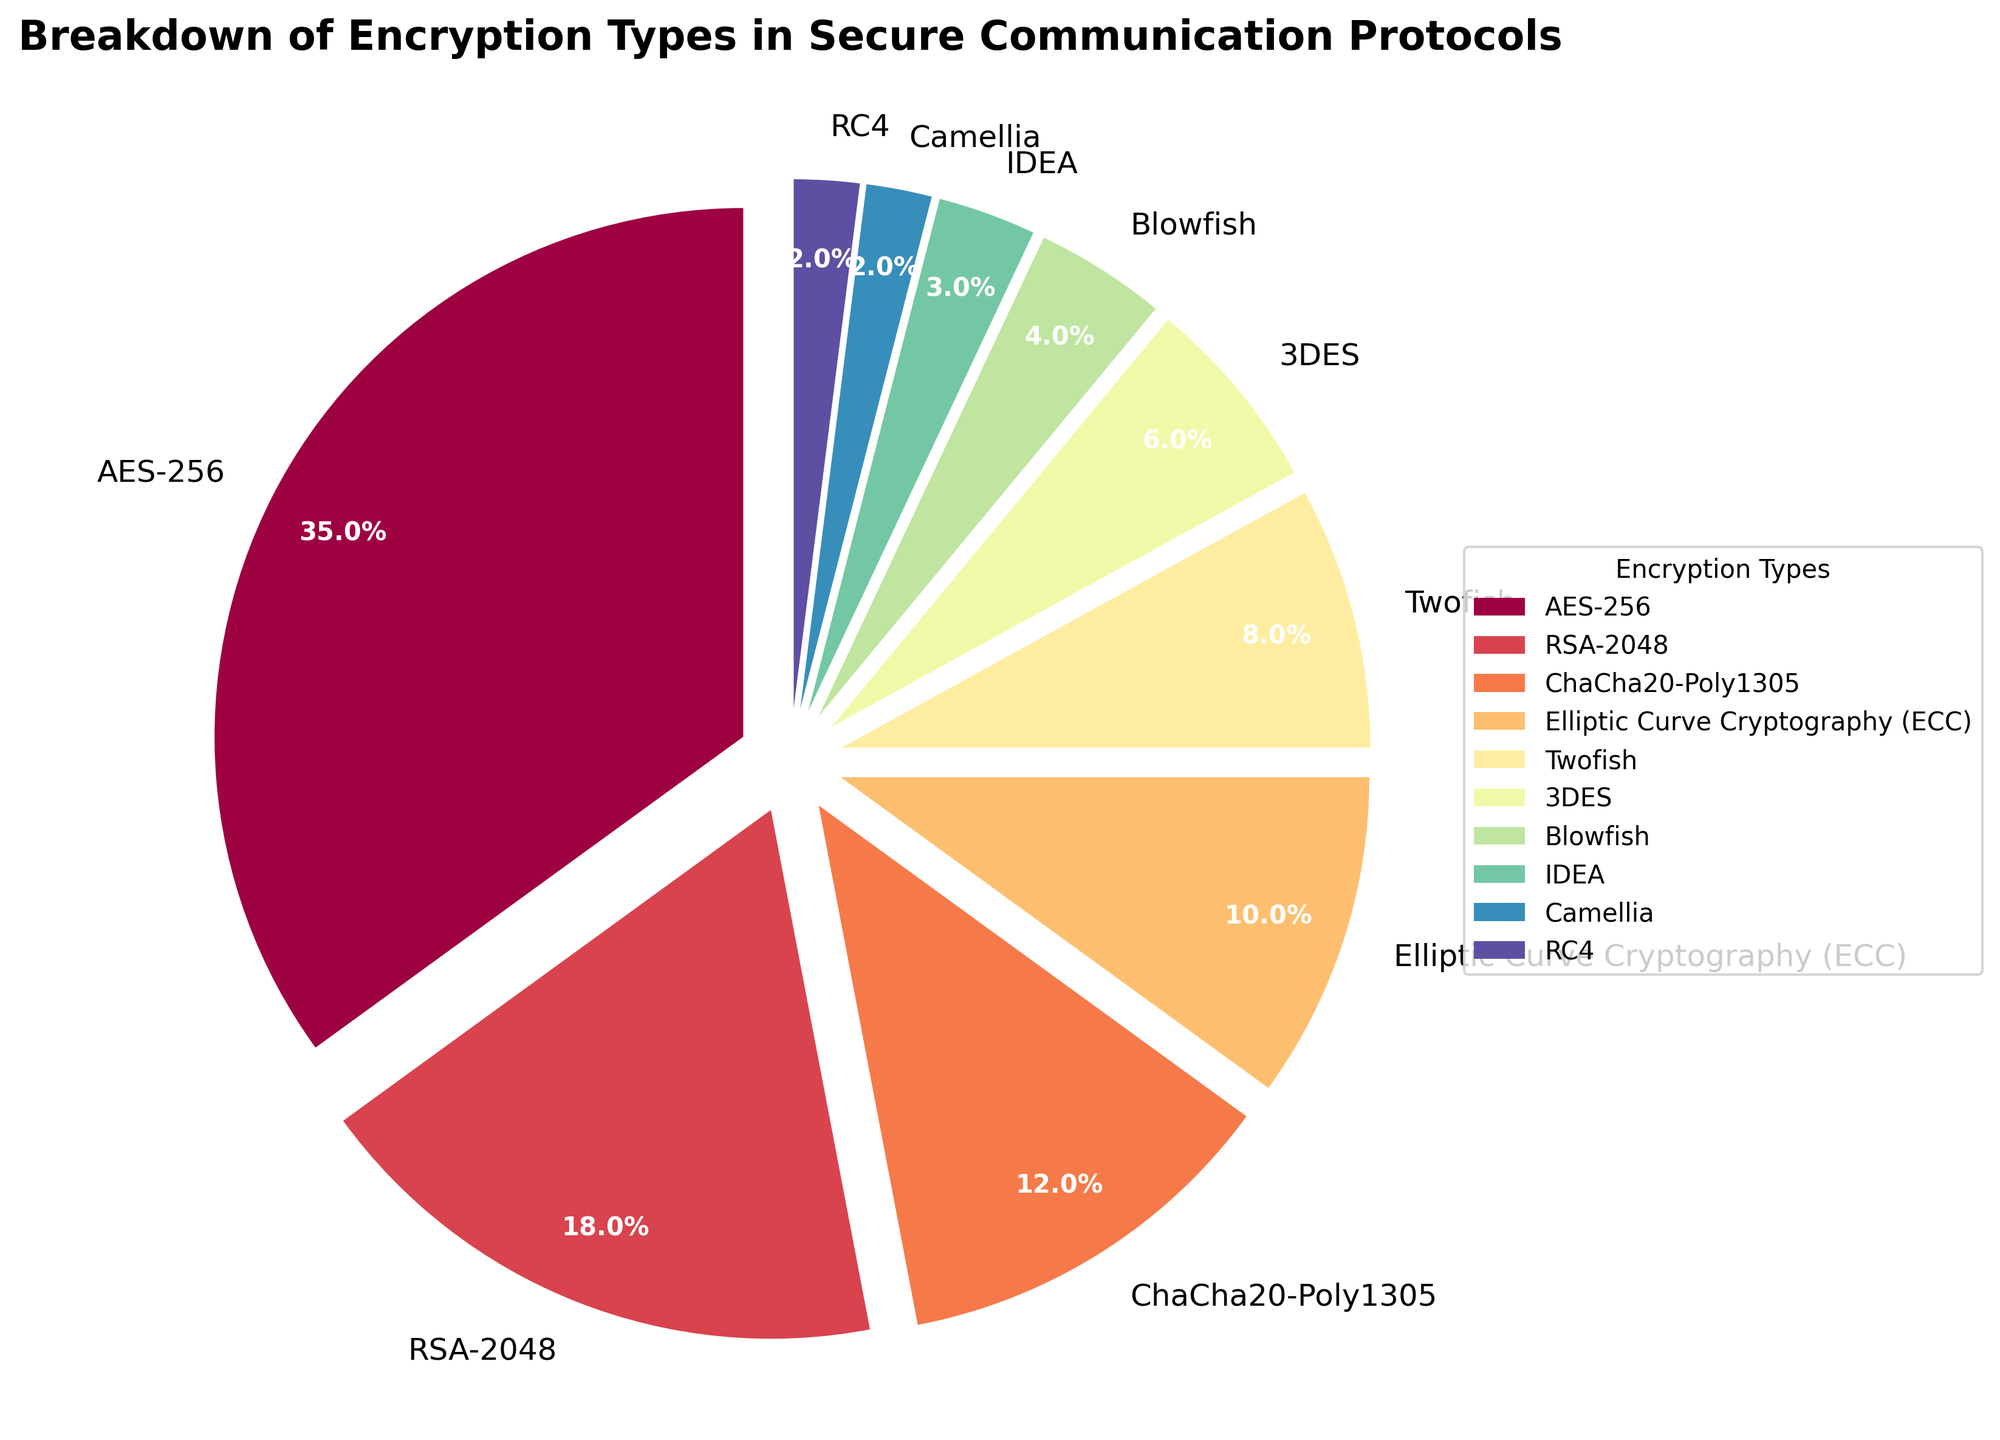What encryption type has the largest percentage in the breakdown? By examining the figure, we can see that AES-256 occupies the largest segment of the pie chart. It is labeled with the highest percentage.
Answer: AES-256 Which encryption type has the smallest percentage, and what is that percentage? Look at the pie chart for the smallest segment. Camellia and RC4 both have the smallest slices, each labeled with 2%.
Answer: Camellia and RC4; 2% What is the combined percentage of RSA-2048 and Elliptic Curve Cryptography (ECC)? Find the two encryption types on the graph and sum their percentages: RSA-2048 (18%) and Elliptic Curve Cryptography (10%). The sum is 18% + 10% = 28%.
Answer: 28% How much larger is the percentage of AES-256 compared to ChaCha20-Poly1305? Subtract the percentage of ChaCha20-Poly1305 (12%) from the percentage of AES-256 (35%). The difference is 35% - 12% = 23%.
Answer: 23% What is the total percentage represented by the encryption types Twofish, 3DES, and Blowfish combined? Add the percentages of Twofish (8%), 3DES (6%), and Blowfish (4%). The total is 8% + 6% + 4% = 18%.
Answer: 18% Which encryption types have a percentage higher than 10% but less than 20%? Identify the segments with percentages higher than 10% but below 20%. These are RSA-2048 (18%) and ChaCha20-Poly1305 (12%).
Answer: RSA-2048 and ChaCha20-Poly1305 If AES-256 represents 35% of the encryption types, how many times smaller is the percentage of IDEA in comparison? Divide the percentage of AES-256 (35%) by the percentage of IDEA (3%). The result is 35 / 3 ≈ 11.67 times smaller.
Answer: Approximately 11.67 times Which encryption types are represented by colors in the blue spectrum, and what are their percentages? Examine the legend on the pie chart for segments colored in different shades of blue, then find their corresponding encryption types and percentages. Assuming the question refers to the least-presented portion of the color map, Elliptic Curve Cryptography (ECC) is in a blue shade with 10%.
Answer: Elliptic Curve Cryptography (ECC); 10% 